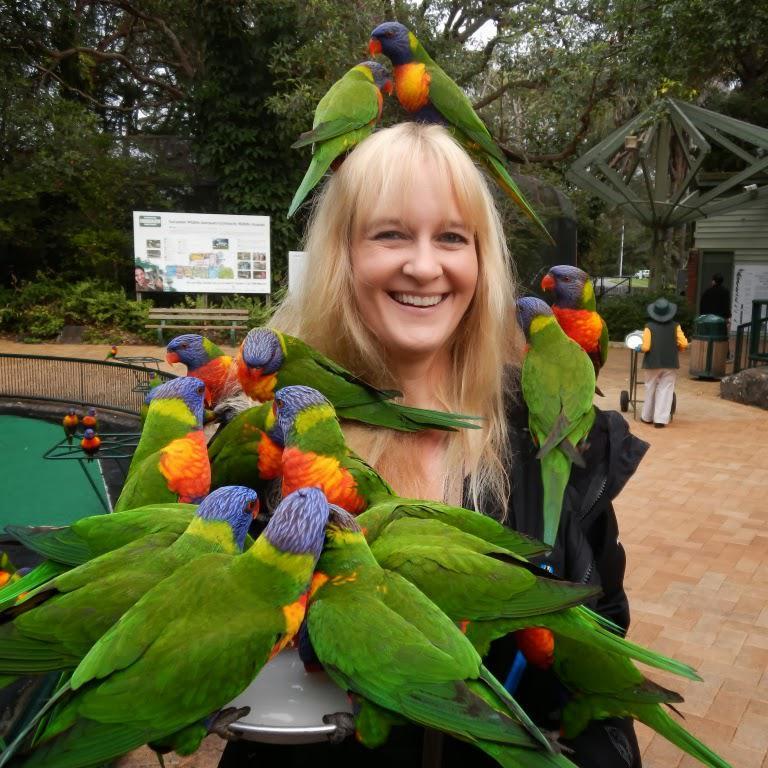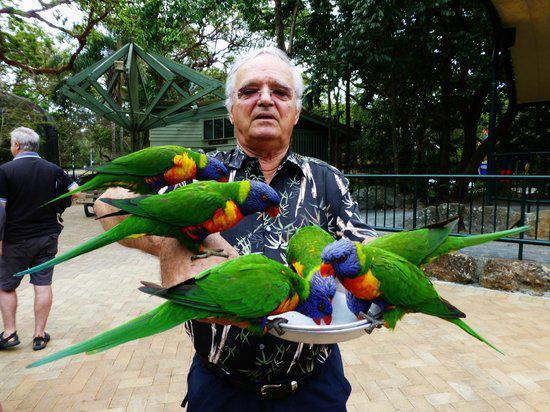The first image is the image on the left, the second image is the image on the right. Analyze the images presented: Is the assertion "Birds are perched on a male in the image on the right and at least one female in the image on the left." valid? Answer yes or no. Yes. The first image is the image on the left, the second image is the image on the right. For the images shown, is this caption "There is one human feeding birds in every image." true? Answer yes or no. Yes. 